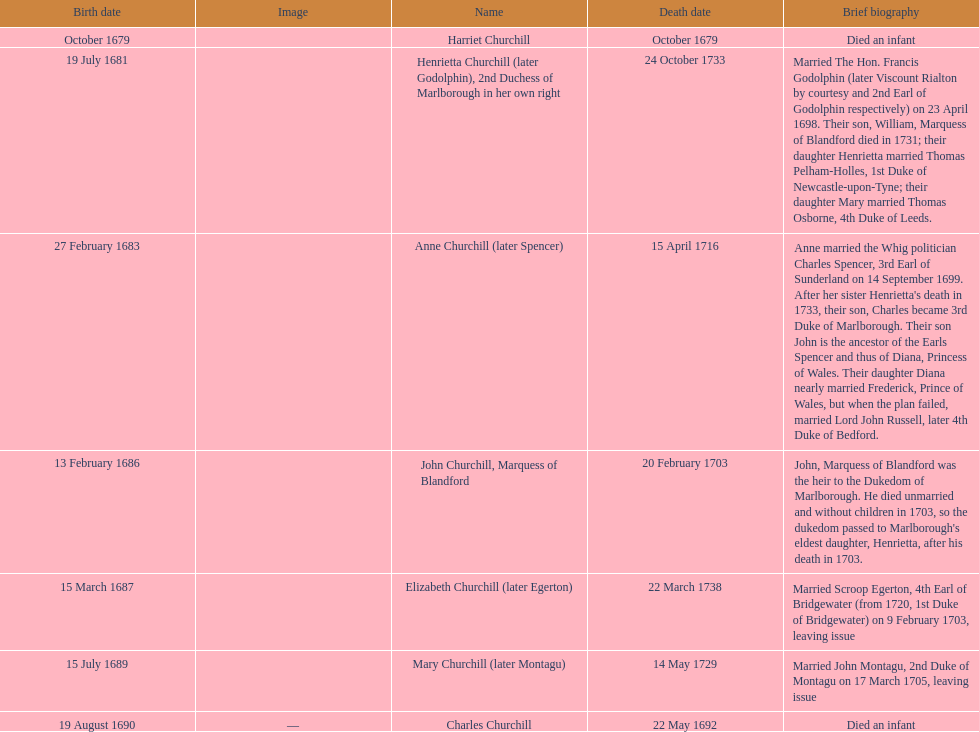What is the total number of children born after 1675? 7. 